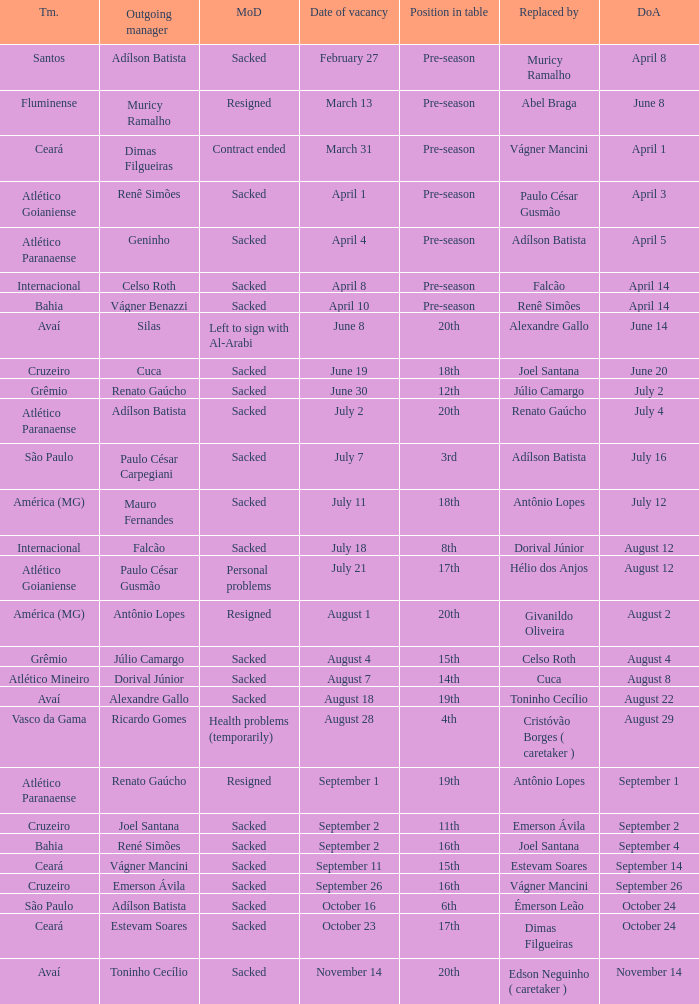Who was replaced as manager on June 20? Cuca. 